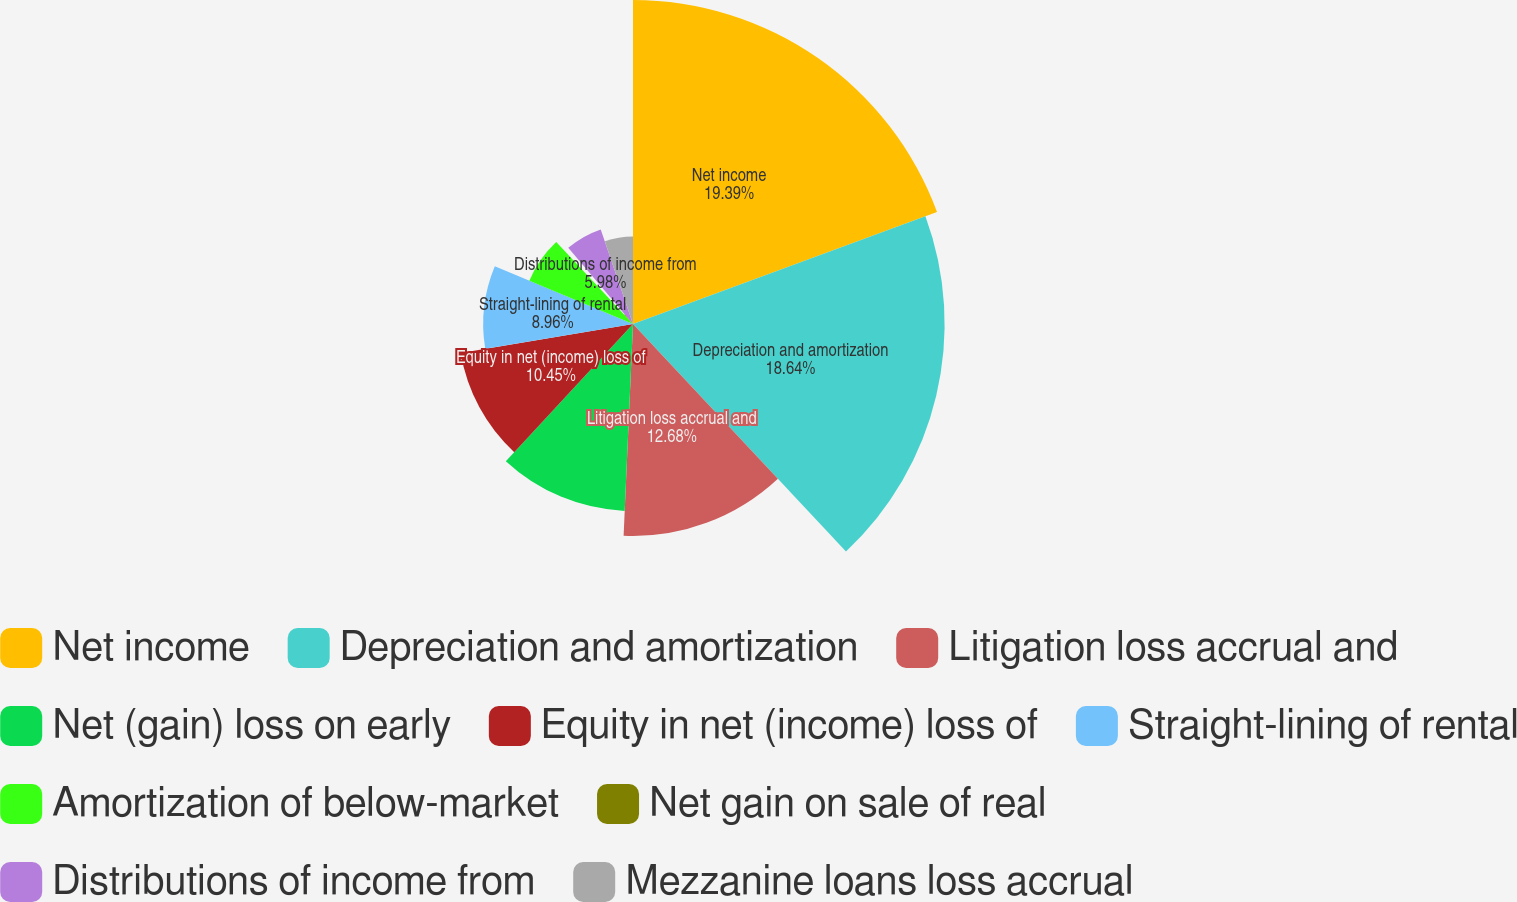<chart> <loc_0><loc_0><loc_500><loc_500><pie_chart><fcel>Net income<fcel>Depreciation and amortization<fcel>Litigation loss accrual and<fcel>Net (gain) loss on early<fcel>Equity in net (income) loss of<fcel>Straight-lining of rental<fcel>Amortization of below-market<fcel>Net gain on sale of real<fcel>Distributions of income from<fcel>Mezzanine loans loss accrual<nl><fcel>19.38%<fcel>18.64%<fcel>12.68%<fcel>11.19%<fcel>10.45%<fcel>8.96%<fcel>6.72%<fcel>0.76%<fcel>5.98%<fcel>5.23%<nl></chart> 